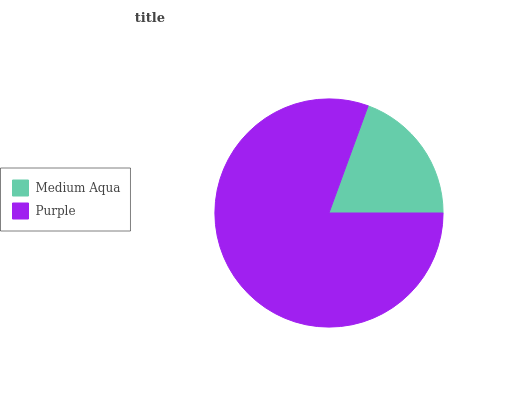Is Medium Aqua the minimum?
Answer yes or no. Yes. Is Purple the maximum?
Answer yes or no. Yes. Is Purple the minimum?
Answer yes or no. No. Is Purple greater than Medium Aqua?
Answer yes or no. Yes. Is Medium Aqua less than Purple?
Answer yes or no. Yes. Is Medium Aqua greater than Purple?
Answer yes or no. No. Is Purple less than Medium Aqua?
Answer yes or no. No. Is Purple the high median?
Answer yes or no. Yes. Is Medium Aqua the low median?
Answer yes or no. Yes. Is Medium Aqua the high median?
Answer yes or no. No. Is Purple the low median?
Answer yes or no. No. 